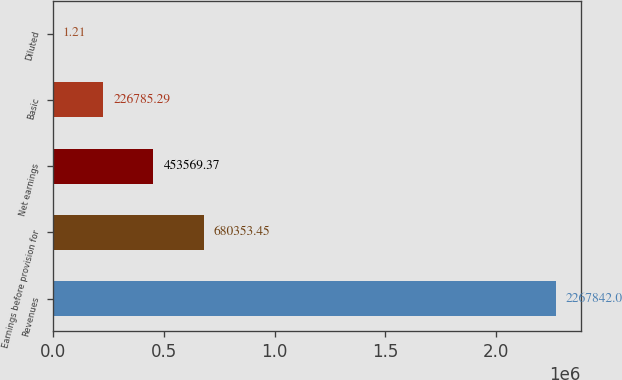<chart> <loc_0><loc_0><loc_500><loc_500><bar_chart><fcel>Revenues<fcel>Earnings before provision for<fcel>Net earnings<fcel>Basic<fcel>Diluted<nl><fcel>2.26784e+06<fcel>680353<fcel>453569<fcel>226785<fcel>1.21<nl></chart> 